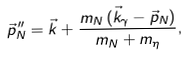<formula> <loc_0><loc_0><loc_500><loc_500>\vec { p } _ { N } ^ { \, \prime \prime } = \vec { k } + \frac { m _ { N } \, ( \vec { k } _ { \gamma } - \vec { p } _ { N } ) } { m _ { N } + m _ { \eta } } ,</formula> 